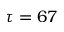<formula> <loc_0><loc_0><loc_500><loc_500>\tau = 6 7</formula> 